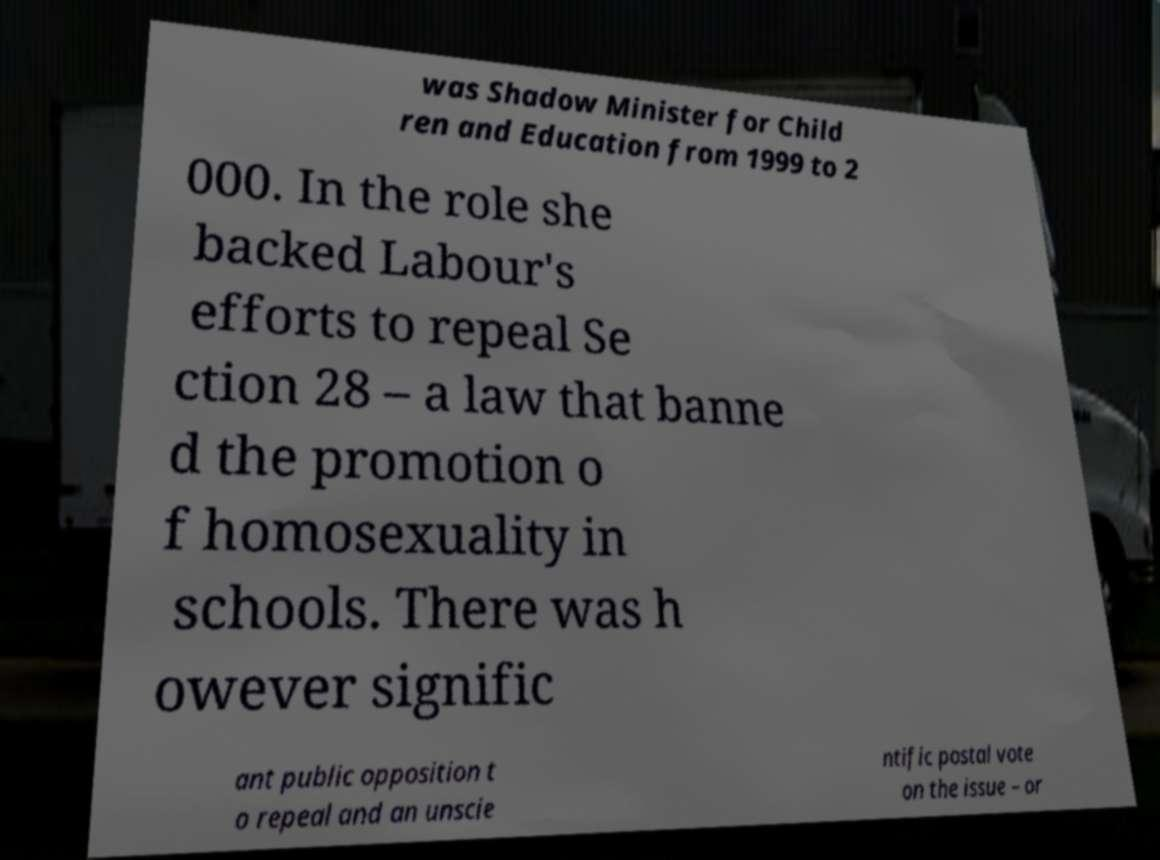Could you extract and type out the text from this image? was Shadow Minister for Child ren and Education from 1999 to 2 000. In the role she backed Labour's efforts to repeal Se ction 28 – a law that banne d the promotion o f homosexuality in schools. There was h owever signific ant public opposition t o repeal and an unscie ntific postal vote on the issue – or 